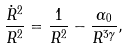Convert formula to latex. <formula><loc_0><loc_0><loc_500><loc_500>\frac { \dot { R } ^ { 2 } } { R ^ { 2 } } = \frac { 1 } { R ^ { 2 } } - \frac { \alpha _ { 0 } } { R ^ { 3 \gamma } } ,</formula> 